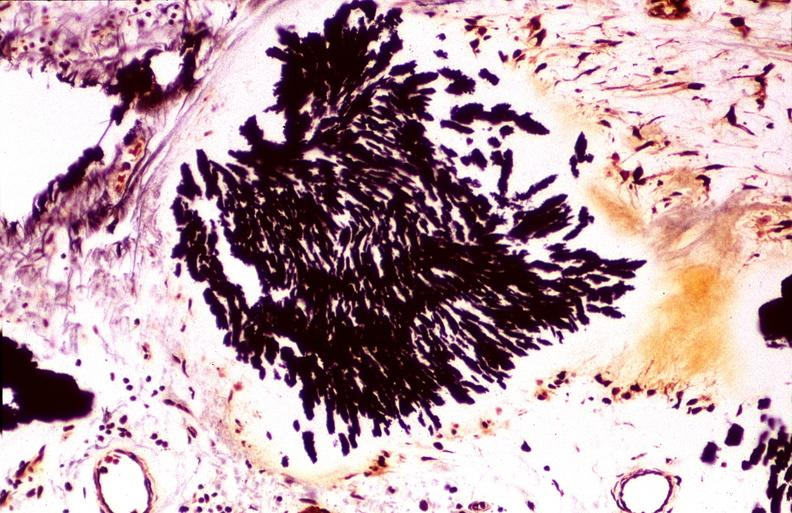s fixed tissue lateral view of vertebral bodies with many present?
Answer the question using a single word or phrase. No 